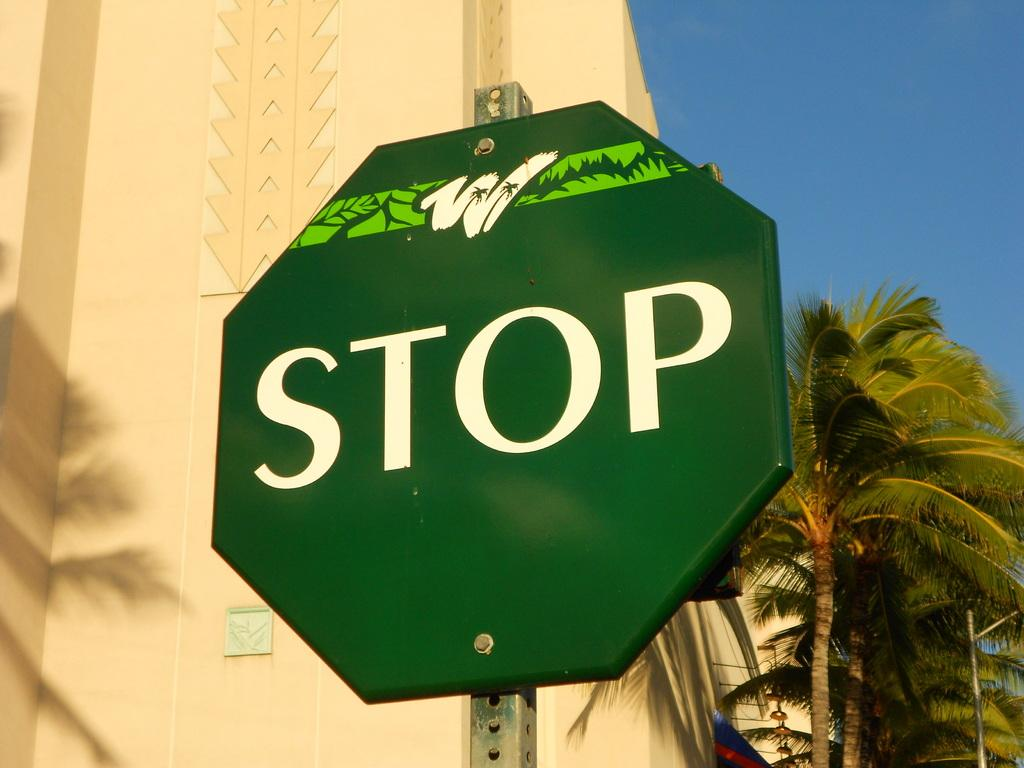Provide a one-sentence caption for the provided image. A green STOP sign with a white W with palm trees in it on the top. 